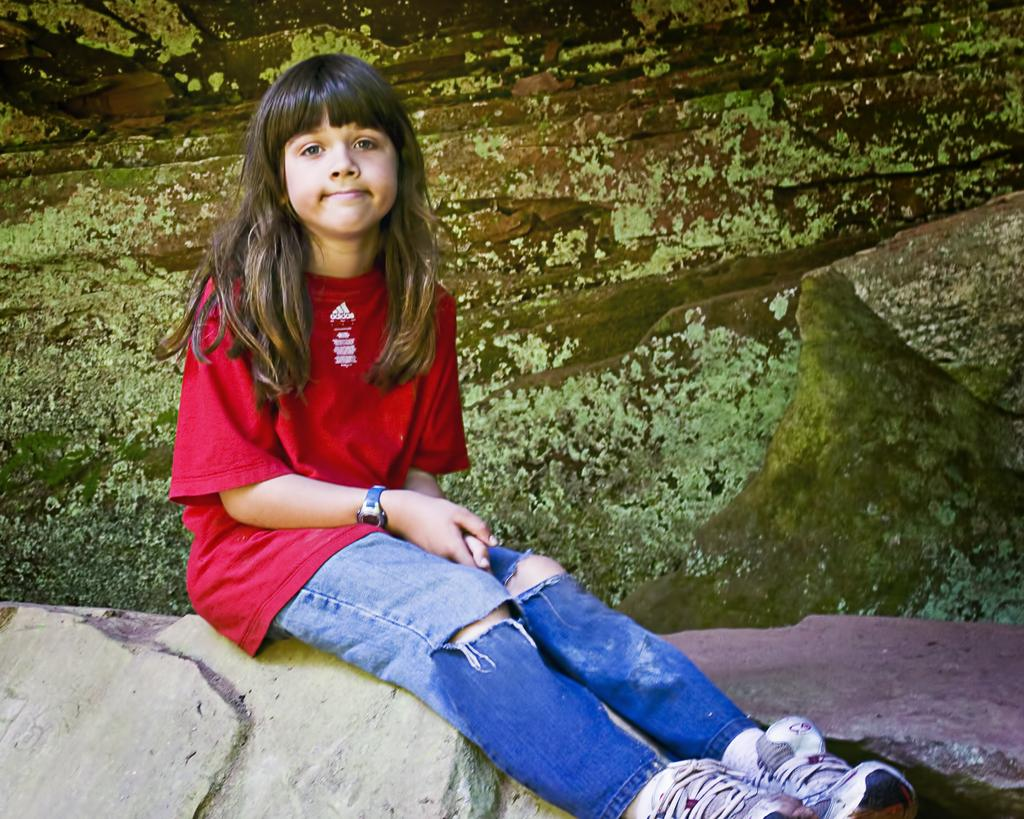Who is the main subject in the image? There is a girl in the image. What is the girl wearing? The girl is wearing a red shirt. Where is the girl sitting? The girl is sitting on rocks. What can be seen in the background of the image? There are rocks and grass in the background of the image. What type of thread is the girl using to play the guitar in the image? There is no guitar present in the image, and therefore no thread can be associated with it. 